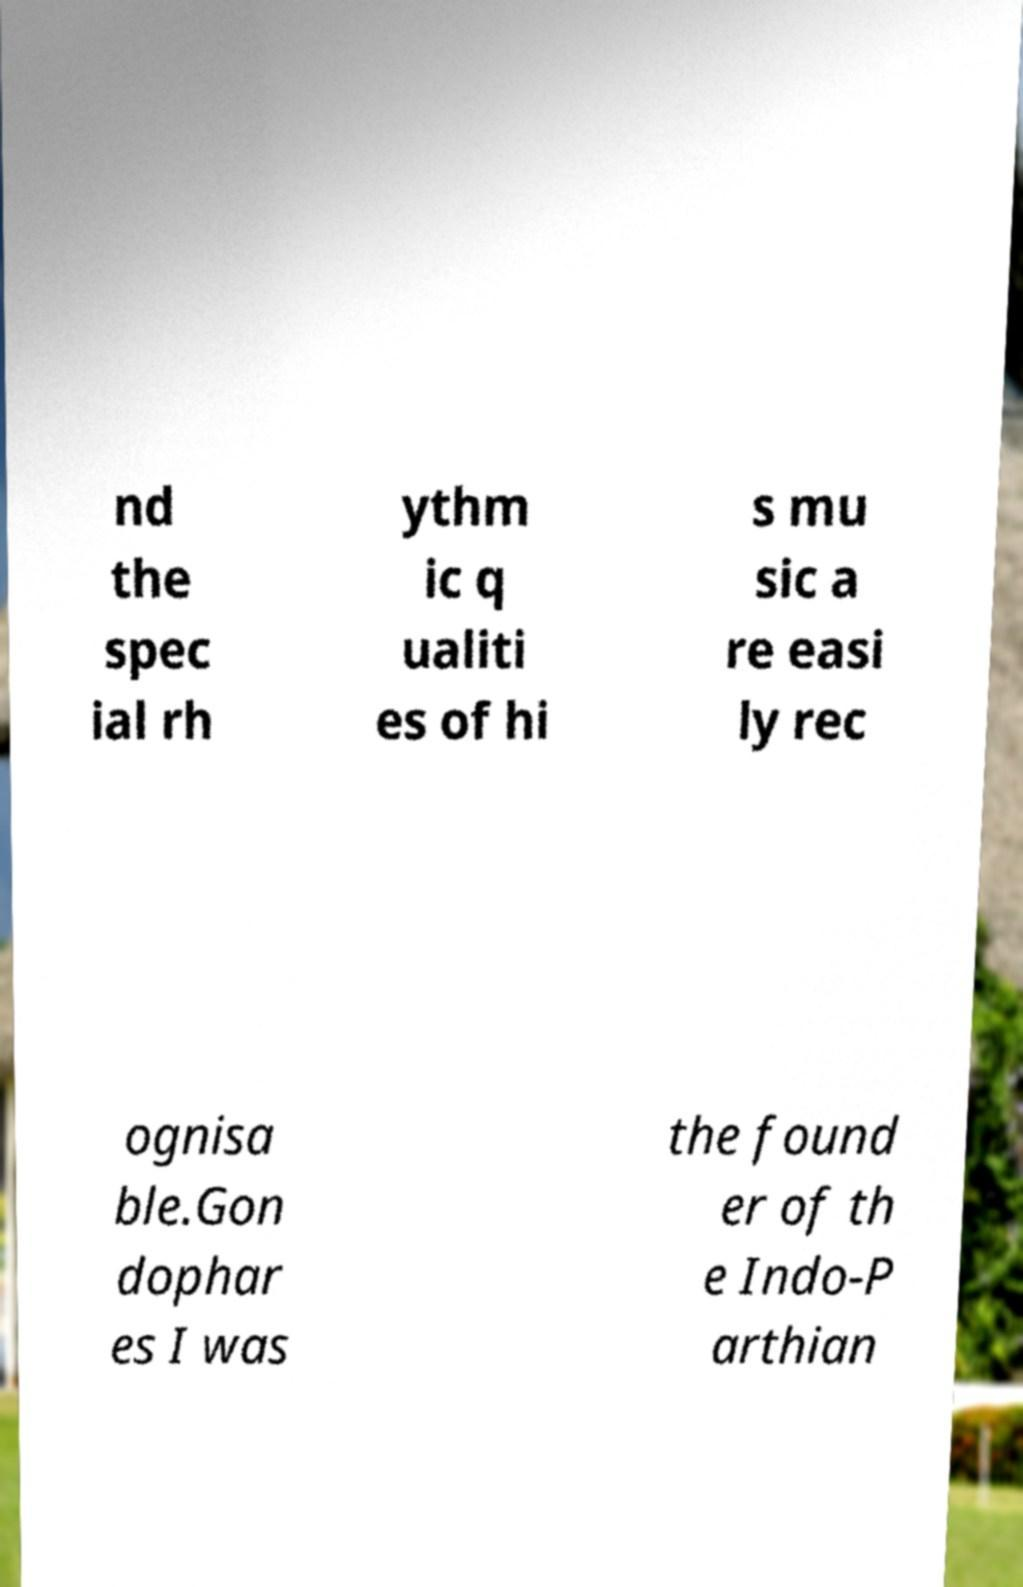Could you assist in decoding the text presented in this image and type it out clearly? nd the spec ial rh ythm ic q ualiti es of hi s mu sic a re easi ly rec ognisa ble.Gon dophar es I was the found er of th e Indo-P arthian 